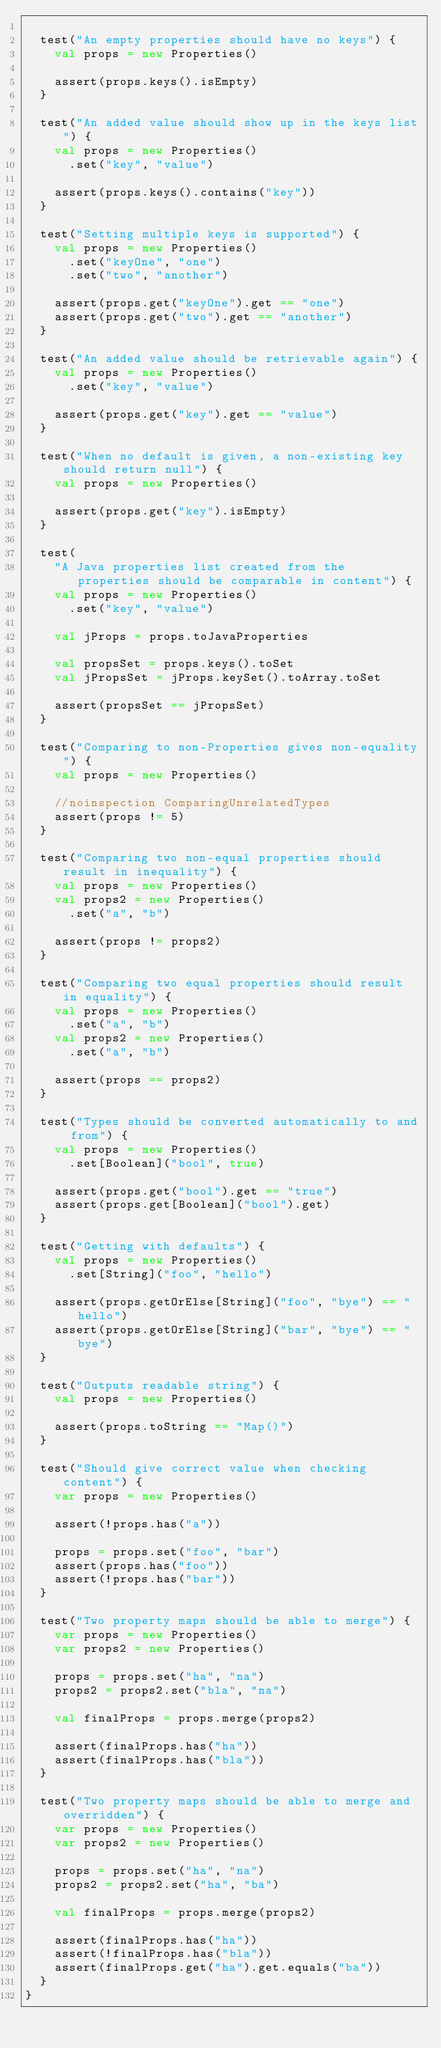<code> <loc_0><loc_0><loc_500><loc_500><_Scala_>
  test("An empty properties should have no keys") {
    val props = new Properties()

    assert(props.keys().isEmpty)
  }

  test("An added value should show up in the keys list") {
    val props = new Properties()
      .set("key", "value")

    assert(props.keys().contains("key"))
  }

  test("Setting multiple keys is supported") {
    val props = new Properties()
      .set("keyOne", "one")
      .set("two", "another")

    assert(props.get("keyOne").get == "one")
    assert(props.get("two").get == "another")
  }

  test("An added value should be retrievable again") {
    val props = new Properties()
      .set("key", "value")

    assert(props.get("key").get == "value")
  }

  test("When no default is given, a non-existing key should return null") {
    val props = new Properties()

    assert(props.get("key").isEmpty)
  }

  test(
    "A Java properties list created from the properties should be comparable in content") {
    val props = new Properties()
      .set("key", "value")

    val jProps = props.toJavaProperties

    val propsSet = props.keys().toSet
    val jPropsSet = jProps.keySet().toArray.toSet

    assert(propsSet == jPropsSet)
  }

  test("Comparing to non-Properties gives non-equality") {
    val props = new Properties()

    //noinspection ComparingUnrelatedTypes
    assert(props != 5)
  }

  test("Comparing two non-equal properties should result in inequality") {
    val props = new Properties()
    val props2 = new Properties()
      .set("a", "b")

    assert(props != props2)
  }

  test("Comparing two equal properties should result in equality") {
    val props = new Properties()
      .set("a", "b")
    val props2 = new Properties()
      .set("a", "b")

    assert(props == props2)
  }

  test("Types should be converted automatically to and from") {
    val props = new Properties()
      .set[Boolean]("bool", true)

    assert(props.get("bool").get == "true")
    assert(props.get[Boolean]("bool").get)
  }

  test("Getting with defaults") {
    val props = new Properties()
      .set[String]("foo", "hello")

    assert(props.getOrElse[String]("foo", "bye") == "hello")
    assert(props.getOrElse[String]("bar", "bye") == "bye")
  }

  test("Outputs readable string") {
    val props = new Properties()

    assert(props.toString == "Map()")
  }

  test("Should give correct value when checking content") {
    var props = new Properties()

    assert(!props.has("a"))

    props = props.set("foo", "bar")
    assert(props.has("foo"))
    assert(!props.has("bar"))
  }

  test("Two property maps should be able to merge") {
    var props = new Properties()
    var props2 = new Properties()

    props = props.set("ha", "na")
    props2 = props2.set("bla", "na")

    val finalProps = props.merge(props2)

    assert(finalProps.has("ha"))
    assert(finalProps.has("bla"))
  }

  test("Two property maps should be able to merge and overridden") {
    var props = new Properties()
    var props2 = new Properties()

    props = props.set("ha", "na")
    props2 = props2.set("ha", "ba")

    val finalProps = props.merge(props2)

    assert(finalProps.has("ha"))
    assert(!finalProps.has("bla"))
    assert(finalProps.get("ha").get.equals("ba"))
  }
}
</code> 